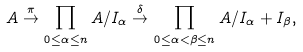<formula> <loc_0><loc_0><loc_500><loc_500>A \stackrel { \pi } { \rightarrow } \prod _ { 0 \leq \alpha \leq n } A / I _ { \alpha } \stackrel { \delta } { \rightarrow } \prod _ { 0 \leq \alpha < \beta \leq n } A / I _ { \alpha } + I _ { \beta } ,</formula> 